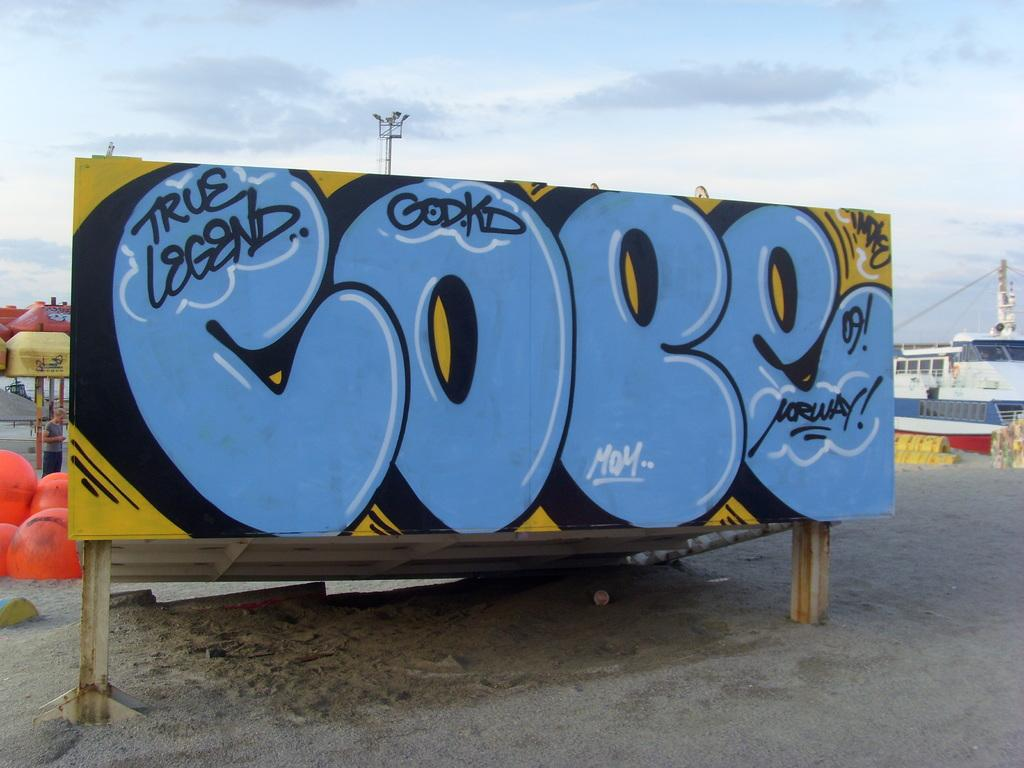<image>
Summarize the visual content of the image. A large billboard features a graffiti style design that says, "True Legend" on it. 